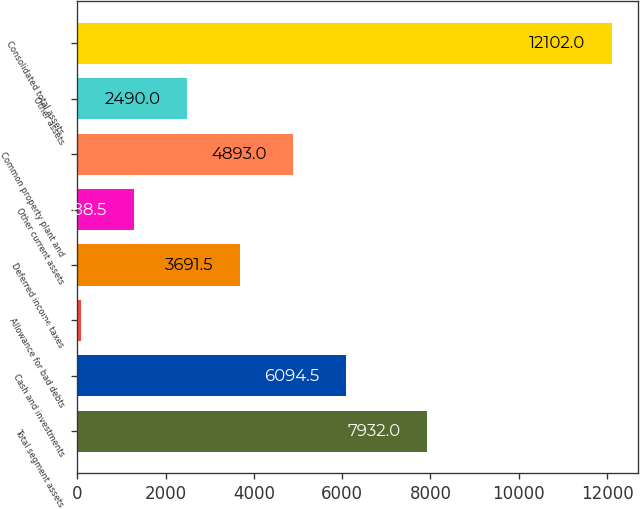<chart> <loc_0><loc_0><loc_500><loc_500><bar_chart><fcel>Total segment assets<fcel>Cash and investments<fcel>Allowance for bad debts<fcel>Deferred income taxes<fcel>Other current assets<fcel>Common property plant and<fcel>Other assets<fcel>Consolidated total assets<nl><fcel>7932<fcel>6094.5<fcel>87<fcel>3691.5<fcel>1288.5<fcel>4893<fcel>2490<fcel>12102<nl></chart> 